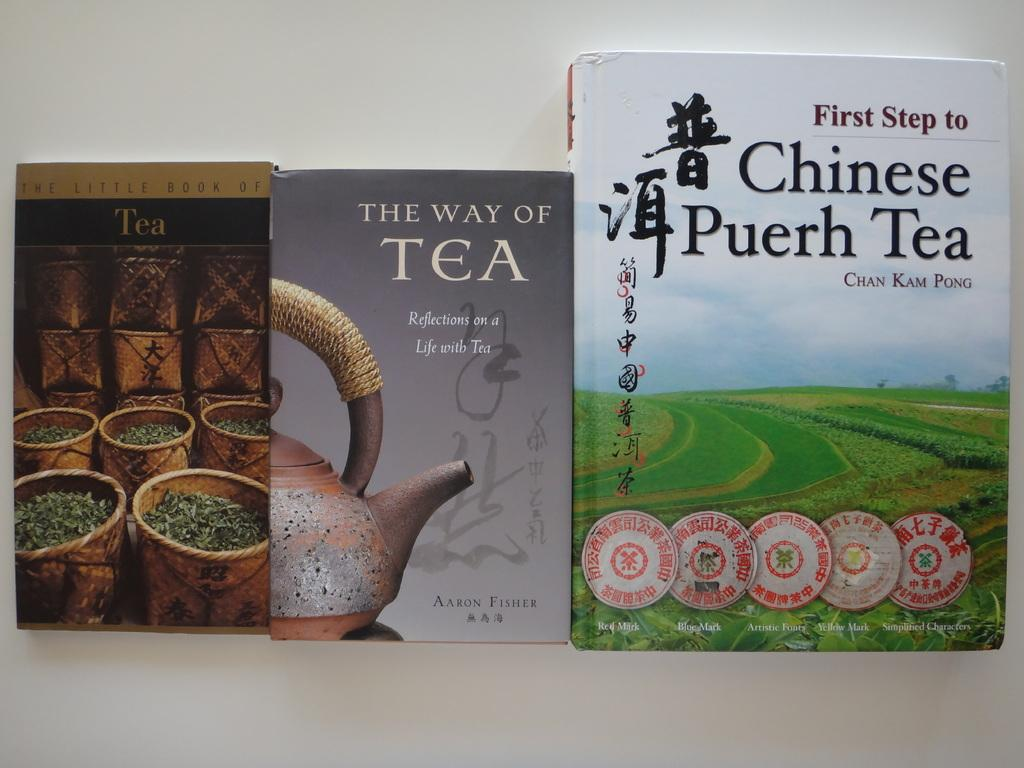<image>
Provide a brief description of the given image. Book with the title Chinese Puerh Tea on the cover. 